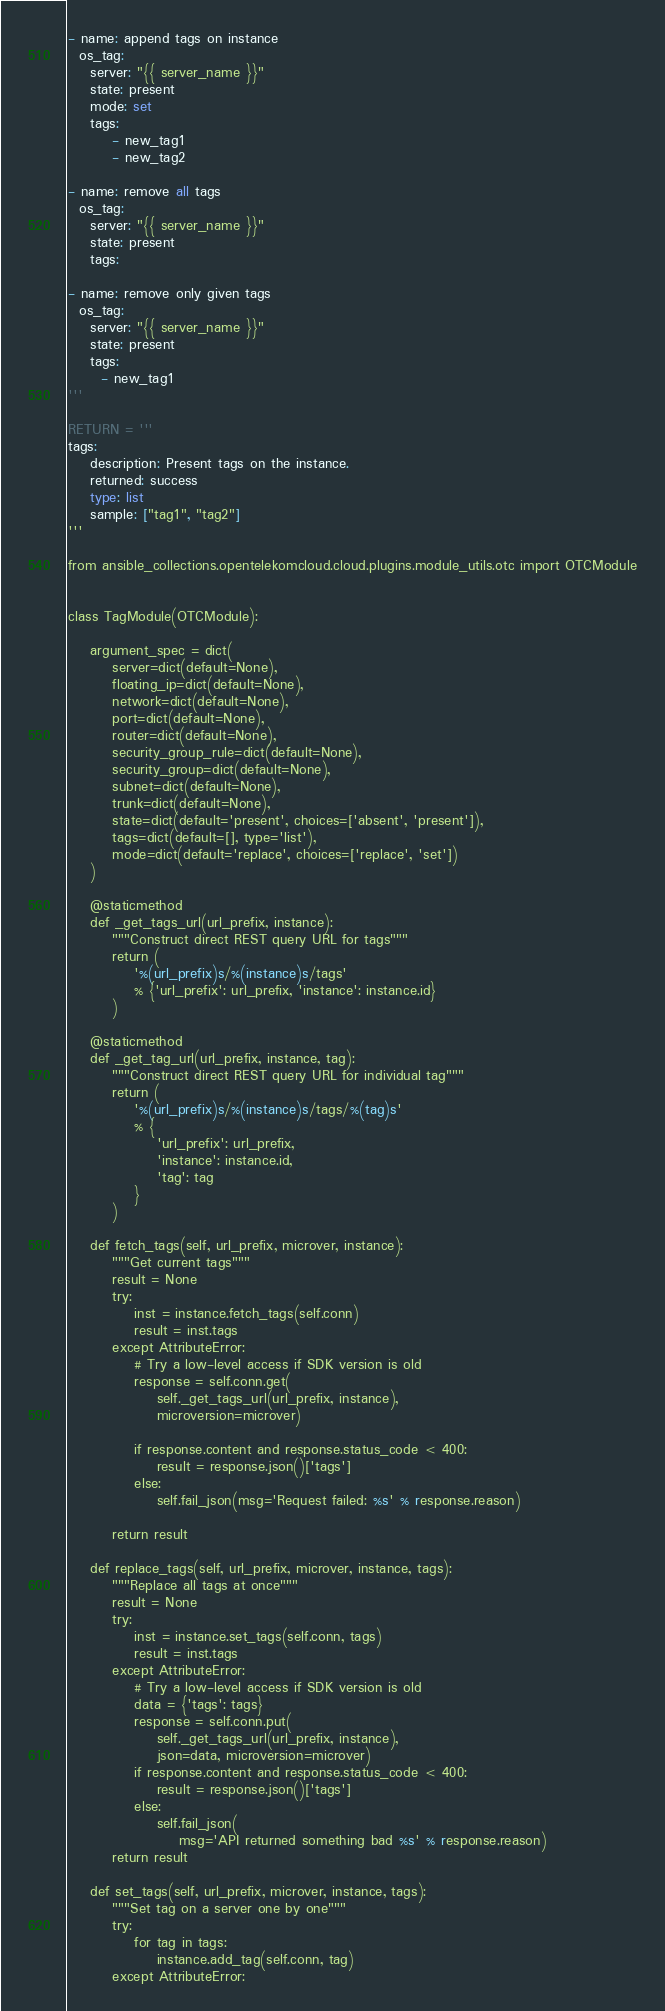Convert code to text. <code><loc_0><loc_0><loc_500><loc_500><_Python_>
- name: append tags on instance
  os_tag:
    server: "{{ server_name }}"
    state: present
    mode: set
    tags:
        - new_tag1
        - new_tag2

- name: remove all tags
  os_tag:
    server: "{{ server_name }}"
    state: present
    tags:

- name: remove only given tags
  os_tag:
    server: "{{ server_name }}"
    state: present
    tags:
      - new_tag1
'''

RETURN = '''
tags:
    description: Present tags on the instance.
    returned: success
    type: list
    sample: ["tag1", "tag2"]
'''

from ansible_collections.opentelekomcloud.cloud.plugins.module_utils.otc import OTCModule


class TagModule(OTCModule):

    argument_spec = dict(
        server=dict(default=None),
        floating_ip=dict(default=None),
        network=dict(default=None),
        port=dict(default=None),
        router=dict(default=None),
        security_group_rule=dict(default=None),
        security_group=dict(default=None),
        subnet=dict(default=None),
        trunk=dict(default=None),
        state=dict(default='present', choices=['absent', 'present']),
        tags=dict(default=[], type='list'),
        mode=dict(default='replace', choices=['replace', 'set'])
    )

    @staticmethod
    def _get_tags_url(url_prefix, instance):
        """Construct direct REST query URL for tags"""
        return (
            '%(url_prefix)s/%(instance)s/tags'
            % {'url_prefix': url_prefix, 'instance': instance.id}
        )

    @staticmethod
    def _get_tag_url(url_prefix, instance, tag):
        """Construct direct REST query URL for individual tag"""
        return (
            '%(url_prefix)s/%(instance)s/tags/%(tag)s'
            % {
                'url_prefix': url_prefix,
                'instance': instance.id,
                'tag': tag
            }
        )

    def fetch_tags(self, url_prefix, microver, instance):
        """Get current tags"""
        result = None
        try:
            inst = instance.fetch_tags(self.conn)
            result = inst.tags
        except AttributeError:
            # Try a low-level access if SDK version is old
            response = self.conn.get(
                self._get_tags_url(url_prefix, instance),
                microversion=microver)

            if response.content and response.status_code < 400:
                result = response.json()['tags']
            else:
                self.fail_json(msg='Request failed: %s' % response.reason)

        return result

    def replace_tags(self, url_prefix, microver, instance, tags):
        """Replace all tags at once"""
        result = None
        try:
            inst = instance.set_tags(self.conn, tags)
            result = inst.tags
        except AttributeError:
            # Try a low-level access if SDK version is old
            data = {'tags': tags}
            response = self.conn.put(
                self._get_tags_url(url_prefix, instance),
                json=data, microversion=microver)
            if response.content and response.status_code < 400:
                result = response.json()['tags']
            else:
                self.fail_json(
                    msg='API returned something bad %s' % response.reason)
        return result

    def set_tags(self, url_prefix, microver, instance, tags):
        """Set tag on a server one by one"""
        try:
            for tag in tags:
                instance.add_tag(self.conn, tag)
        except AttributeError:</code> 